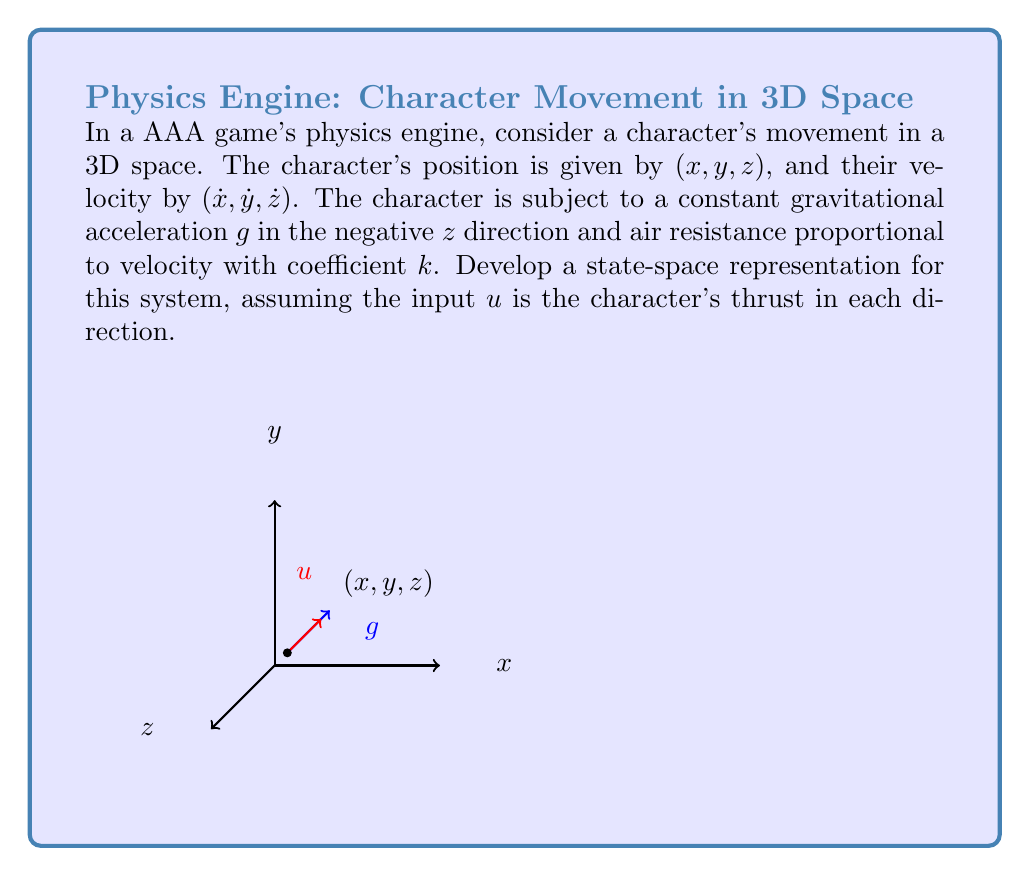Solve this math problem. To develop a state-space representation, we need to define our state variables and their derivatives. Let's approach this step-by-step:

1) State variables: We have 6 state variables
   $x_1 = x$, $x_2 = y$, $x_3 = z$ (positions)
   $x_4 = \dot{x}$, $x_5 = \dot{y}$, $x_6 = \dot{z}$ (velocities)

2) State equations:
   The derivatives of positions are velocities:
   $$\dot{x}_1 = x_4$$
   $$\dot{x}_2 = x_5$$
   $$\dot{x}_3 = x_6$$

3) For velocities, we consider forces:
   - Gravity: Acts only in z-direction with acceleration $-g$
   - Air resistance: Proportional to velocity in each direction, $-kv$
   - Thrust: Input $u = (u_1, u_2, u_3)$ in each direction

   Thus:
   $$\dot{x}_4 = -kx_4 + u_1$$
   $$\dot{x}_5 = -kx_5 + u_2$$
   $$\dot{x}_6 = -g - kx_6 + u_3$$

4) Now we can write our state-space equation in matrix form:

   $$\dot{\mathbf{x}} = A\mathbf{x} + B\mathbf{u} + \mathbf{f}$$

   Where:
   $$A = \begin{bmatrix}
   0 & 0 & 0 & 1 & 0 & 0 \\
   0 & 0 & 0 & 0 & 1 & 0 \\
   0 & 0 & 0 & 0 & 0 & 1 \\
   0 & 0 & 0 & -k & 0 & 0 \\
   0 & 0 & 0 & 0 & -k & 0 \\
   0 & 0 & 0 & 0 & 0 & -k
   \end{bmatrix}$$

   $$B = \begin{bmatrix}
   0 & 0 & 0 \\
   0 & 0 & 0 \\
   0 & 0 & 0 \\
   1 & 0 & 0 \\
   0 & 1 & 0 \\
   0 & 0 & 1
   \end{bmatrix}$$

   $$\mathbf{f} = \begin{bmatrix}
   0 \\ 0 \\ 0 \\ 0 \\ 0 \\ -g
   \end{bmatrix}$$

This state-space representation fully describes the character's motion in the game's 3D space.
Answer: $$\dot{\mathbf{x}} = \begin{bmatrix}
0 & 0 & 0 & 1 & 0 & 0 \\
0 & 0 & 0 & 0 & 1 & 0 \\
0 & 0 & 0 & 0 & 0 & 1 \\
0 & 0 & 0 & -k & 0 & 0 \\
0 & 0 & 0 & 0 & -k & 0 \\
0 & 0 & 0 & 0 & 0 & -k
\end{bmatrix}\mathbf{x} + \begin{bmatrix}
0 & 0 & 0 \\
0 & 0 & 0 \\
0 & 0 & 0 \\
1 & 0 & 0 \\
0 & 1 & 0 \\
0 & 0 & 1
\end{bmatrix}\mathbf{u} + \begin{bmatrix}
0 \\ 0 \\ 0 \\ 0 \\ 0 \\ -g
\end{bmatrix}$$ 